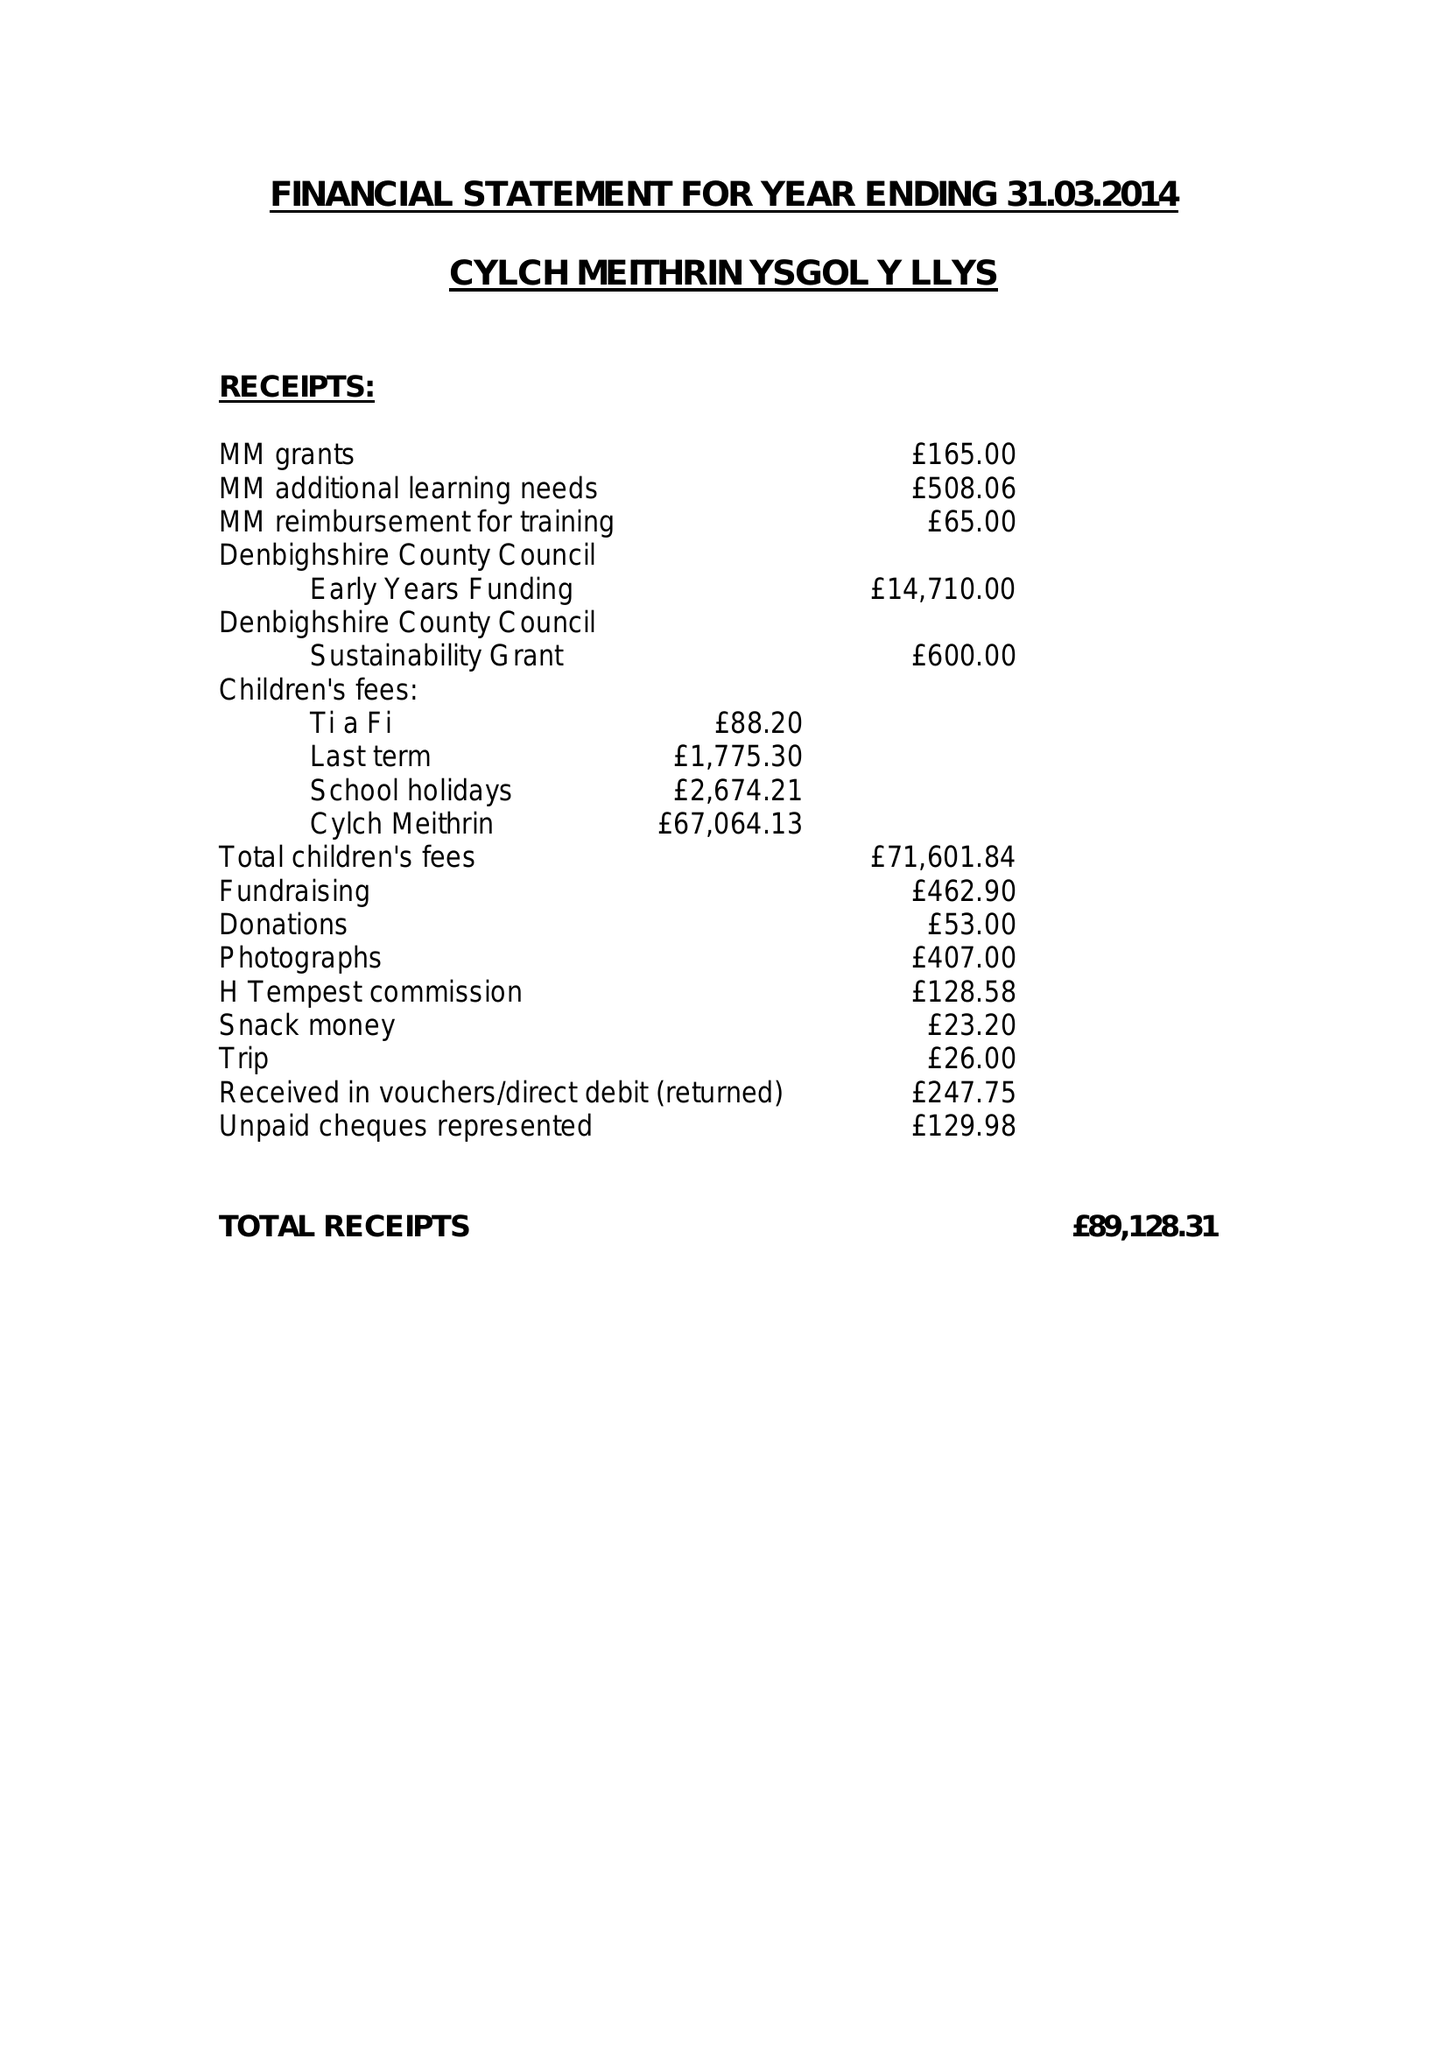What is the value for the charity_name?
Answer the question using a single word or phrase. Cylch Meithrin Y Llys 